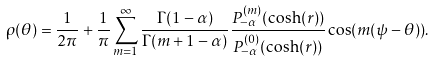<formula> <loc_0><loc_0><loc_500><loc_500>\rho ( \theta ) = \frac { 1 } { 2 \pi } + \frac { 1 } { \pi } \sum _ { m = 1 } ^ { \infty } \frac { \Gamma ( 1 - \alpha ) } { \Gamma ( m + 1 - \alpha ) } \frac { P _ { - \alpha } ^ { ( m ) } ( \cosh ( r ) ) } { P _ { - \alpha } ^ { ( 0 ) } ( \cosh ( r ) ) } \cos ( m ( \psi - \theta ) ) .</formula> 